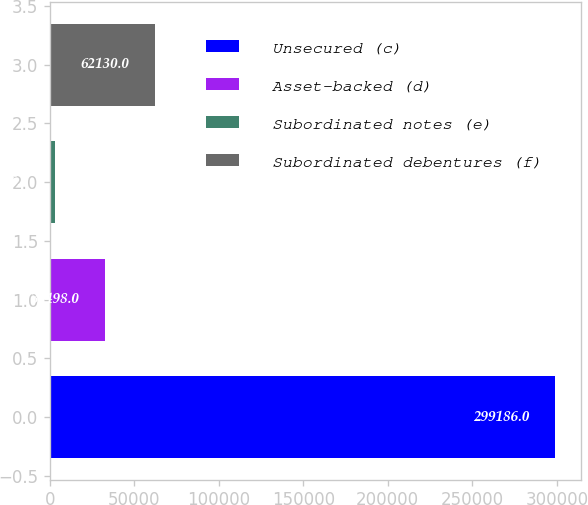Convert chart. <chart><loc_0><loc_0><loc_500><loc_500><bar_chart><fcel>Unsecured (c)<fcel>Asset-backed (d)<fcel>Subordinated notes (e)<fcel>Subordinated debentures (f)<nl><fcel>299186<fcel>32498<fcel>2866<fcel>62130<nl></chart> 